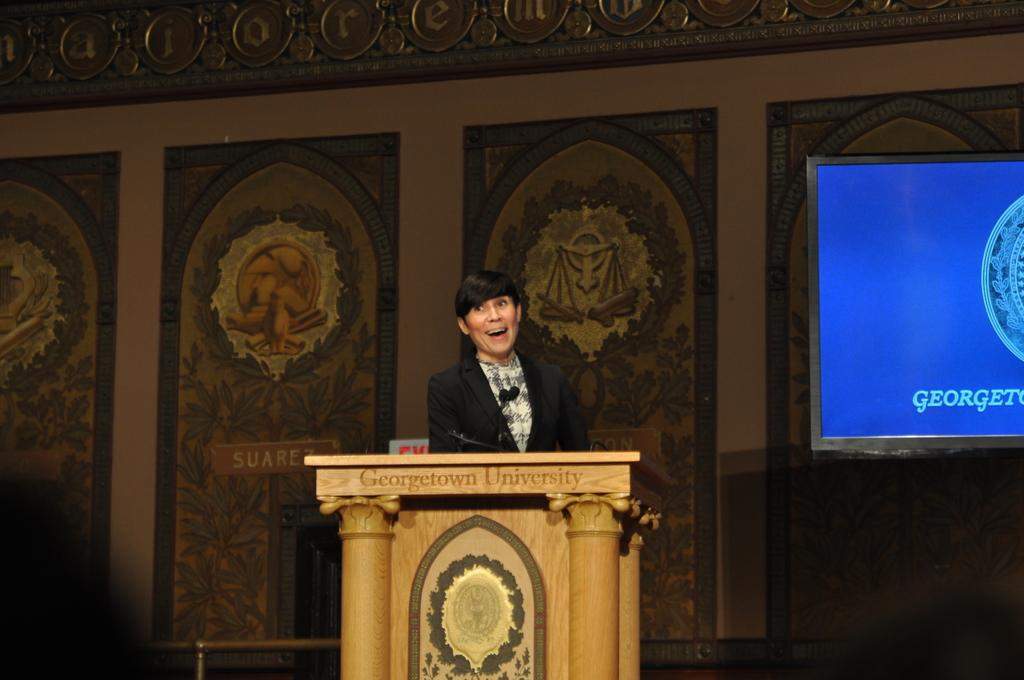What is the person in the image doing? The person is standing in the image. Where is the person standing in relation to the podium? The person is standing in front of a podium. What can be seen on the podium? Microphones are present on the podium. What can be seen in the background of the image? There is a designed wall and a screen in the background of the image. What type of bead is being used to decorate the microphones on the podium? There is no bead present on the microphones or in the image. 